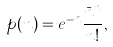Convert formula to latex. <formula><loc_0><loc_0><loc_500><loc_500>p ( n ) = e ^ { - \bar { n } } \frac { { \bar { n } } ^ { n } } { n ! } ,</formula> 